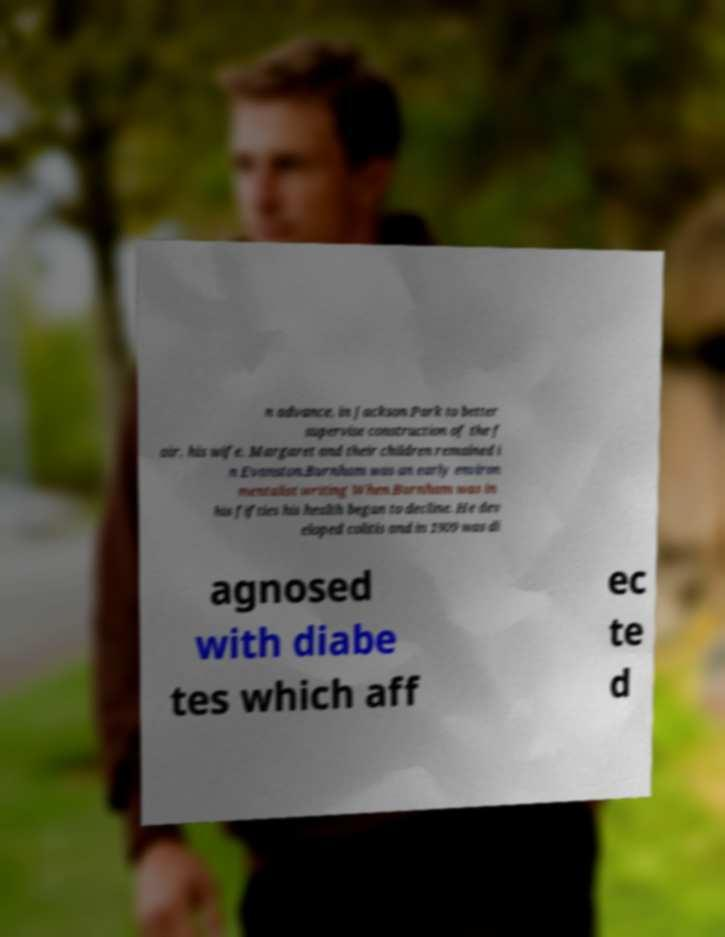Please identify and transcribe the text found in this image. n advance, in Jackson Park to better supervise construction of the f air, his wife, Margaret and their children remained i n Evanston.Burnham was an early environ mentalist writing When Burnham was in his fifties his health began to decline. He dev eloped colitis and in 1909 was di agnosed with diabe tes which aff ec te d 